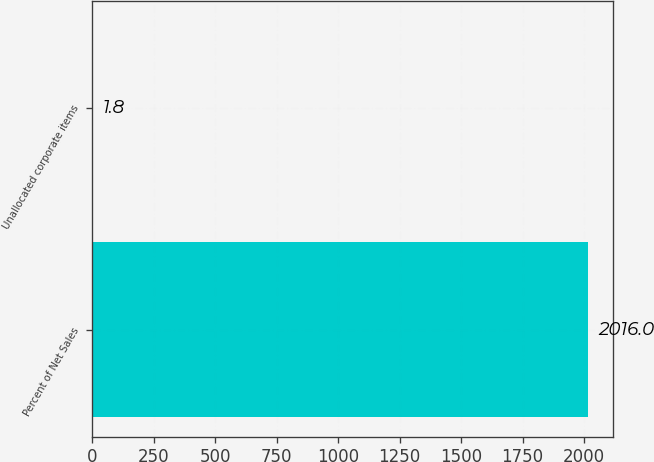Convert chart to OTSL. <chart><loc_0><loc_0><loc_500><loc_500><bar_chart><fcel>Percent of Net Sales<fcel>Unallocated corporate items<nl><fcel>2016<fcel>1.8<nl></chart> 